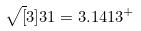<formula> <loc_0><loc_0><loc_500><loc_500>\sqrt { [ } 3 ] { 3 1 } = 3 . 1 4 1 3 ^ { + }</formula> 